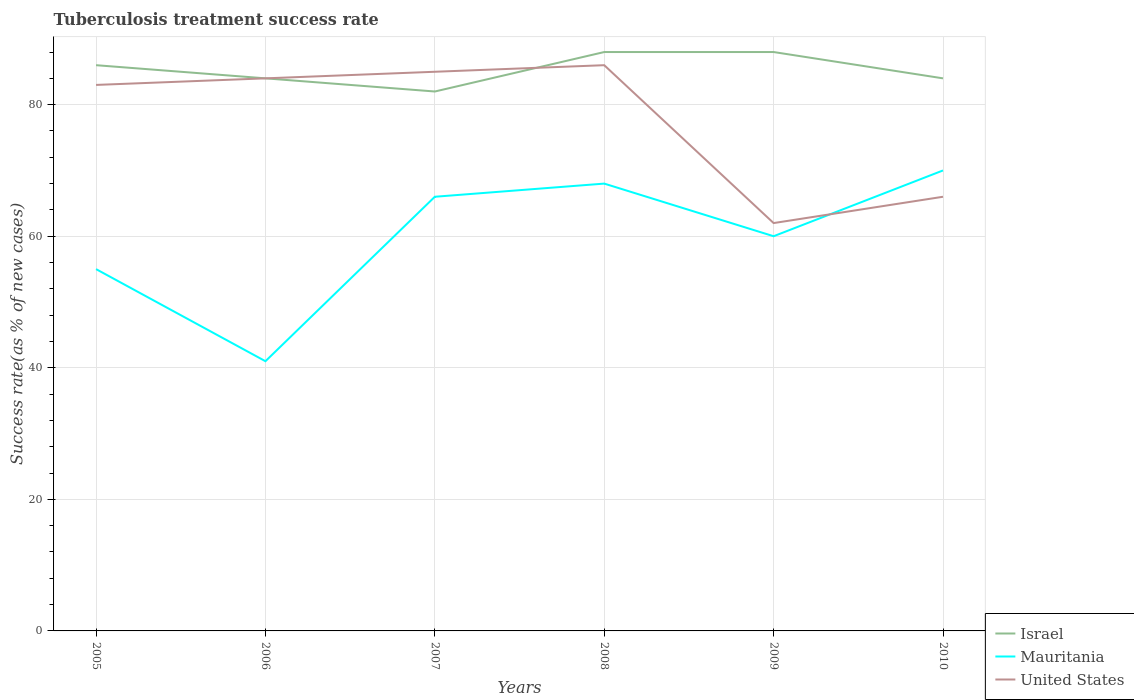How many different coloured lines are there?
Make the answer very short. 3. Does the line corresponding to United States intersect with the line corresponding to Israel?
Provide a short and direct response. Yes. Across all years, what is the maximum tuberculosis treatment success rate in Mauritania?
Provide a short and direct response. 41. What is the difference between the highest and the second highest tuberculosis treatment success rate in Israel?
Offer a terse response. 6. How many years are there in the graph?
Offer a very short reply. 6. What is the difference between two consecutive major ticks on the Y-axis?
Keep it short and to the point. 20. How many legend labels are there?
Your answer should be compact. 3. What is the title of the graph?
Give a very brief answer. Tuberculosis treatment success rate. What is the label or title of the X-axis?
Make the answer very short. Years. What is the label or title of the Y-axis?
Give a very brief answer. Success rate(as % of new cases). What is the Success rate(as % of new cases) of Israel in 2005?
Your answer should be very brief. 86. What is the Success rate(as % of new cases) of Israel in 2006?
Give a very brief answer. 84. What is the Success rate(as % of new cases) of Mauritania in 2006?
Your answer should be compact. 41. What is the Success rate(as % of new cases) in United States in 2006?
Ensure brevity in your answer.  84. What is the Success rate(as % of new cases) of Mauritania in 2007?
Your answer should be compact. 66. What is the Success rate(as % of new cases) of United States in 2008?
Your response must be concise. 86. Across all years, what is the minimum Success rate(as % of new cases) in Israel?
Your response must be concise. 82. What is the total Success rate(as % of new cases) of Israel in the graph?
Give a very brief answer. 512. What is the total Success rate(as % of new cases) of Mauritania in the graph?
Your response must be concise. 360. What is the total Success rate(as % of new cases) of United States in the graph?
Provide a short and direct response. 466. What is the difference between the Success rate(as % of new cases) of Mauritania in 2005 and that in 2006?
Keep it short and to the point. 14. What is the difference between the Success rate(as % of new cases) of Israel in 2005 and that in 2007?
Provide a succinct answer. 4. What is the difference between the Success rate(as % of new cases) of United States in 2005 and that in 2007?
Ensure brevity in your answer.  -2. What is the difference between the Success rate(as % of new cases) in Israel in 2005 and that in 2008?
Your response must be concise. -2. What is the difference between the Success rate(as % of new cases) in Mauritania in 2005 and that in 2008?
Ensure brevity in your answer.  -13. What is the difference between the Success rate(as % of new cases) in United States in 2005 and that in 2008?
Offer a terse response. -3. What is the difference between the Success rate(as % of new cases) of Mauritania in 2005 and that in 2009?
Your answer should be compact. -5. What is the difference between the Success rate(as % of new cases) in United States in 2005 and that in 2009?
Your answer should be very brief. 21. What is the difference between the Success rate(as % of new cases) of Mauritania in 2005 and that in 2010?
Keep it short and to the point. -15. What is the difference between the Success rate(as % of new cases) in United States in 2005 and that in 2010?
Make the answer very short. 17. What is the difference between the Success rate(as % of new cases) of Mauritania in 2006 and that in 2007?
Offer a terse response. -25. What is the difference between the Success rate(as % of new cases) in United States in 2006 and that in 2007?
Offer a terse response. -1. What is the difference between the Success rate(as % of new cases) in Israel in 2006 and that in 2009?
Offer a very short reply. -4. What is the difference between the Success rate(as % of new cases) of Mauritania in 2006 and that in 2009?
Ensure brevity in your answer.  -19. What is the difference between the Success rate(as % of new cases) in United States in 2006 and that in 2010?
Offer a very short reply. 18. What is the difference between the Success rate(as % of new cases) of Mauritania in 2007 and that in 2008?
Keep it short and to the point. -2. What is the difference between the Success rate(as % of new cases) of United States in 2007 and that in 2008?
Ensure brevity in your answer.  -1. What is the difference between the Success rate(as % of new cases) in Israel in 2007 and that in 2009?
Give a very brief answer. -6. What is the difference between the Success rate(as % of new cases) in United States in 2007 and that in 2010?
Make the answer very short. 19. What is the difference between the Success rate(as % of new cases) of Israel in 2008 and that in 2009?
Ensure brevity in your answer.  0. What is the difference between the Success rate(as % of new cases) in United States in 2008 and that in 2009?
Provide a succinct answer. 24. What is the difference between the Success rate(as % of new cases) in Mauritania in 2008 and that in 2010?
Ensure brevity in your answer.  -2. What is the difference between the Success rate(as % of new cases) of Israel in 2009 and that in 2010?
Your answer should be compact. 4. What is the difference between the Success rate(as % of new cases) of Mauritania in 2009 and that in 2010?
Provide a succinct answer. -10. What is the difference between the Success rate(as % of new cases) in United States in 2009 and that in 2010?
Make the answer very short. -4. What is the difference between the Success rate(as % of new cases) of Israel in 2005 and the Success rate(as % of new cases) of Mauritania in 2006?
Provide a succinct answer. 45. What is the difference between the Success rate(as % of new cases) of Israel in 2005 and the Success rate(as % of new cases) of United States in 2007?
Keep it short and to the point. 1. What is the difference between the Success rate(as % of new cases) in Israel in 2005 and the Success rate(as % of new cases) in Mauritania in 2008?
Make the answer very short. 18. What is the difference between the Success rate(as % of new cases) of Mauritania in 2005 and the Success rate(as % of new cases) of United States in 2008?
Give a very brief answer. -31. What is the difference between the Success rate(as % of new cases) in Israel in 2005 and the Success rate(as % of new cases) in Mauritania in 2009?
Provide a succinct answer. 26. What is the difference between the Success rate(as % of new cases) of Israel in 2005 and the Success rate(as % of new cases) of United States in 2009?
Provide a short and direct response. 24. What is the difference between the Success rate(as % of new cases) in Mauritania in 2005 and the Success rate(as % of new cases) in United States in 2009?
Your response must be concise. -7. What is the difference between the Success rate(as % of new cases) of Mauritania in 2005 and the Success rate(as % of new cases) of United States in 2010?
Provide a short and direct response. -11. What is the difference between the Success rate(as % of new cases) of Israel in 2006 and the Success rate(as % of new cases) of Mauritania in 2007?
Keep it short and to the point. 18. What is the difference between the Success rate(as % of new cases) of Israel in 2006 and the Success rate(as % of new cases) of United States in 2007?
Your response must be concise. -1. What is the difference between the Success rate(as % of new cases) in Mauritania in 2006 and the Success rate(as % of new cases) in United States in 2007?
Give a very brief answer. -44. What is the difference between the Success rate(as % of new cases) of Mauritania in 2006 and the Success rate(as % of new cases) of United States in 2008?
Keep it short and to the point. -45. What is the difference between the Success rate(as % of new cases) of Israel in 2006 and the Success rate(as % of new cases) of Mauritania in 2009?
Offer a very short reply. 24. What is the difference between the Success rate(as % of new cases) of Israel in 2006 and the Success rate(as % of new cases) of United States in 2009?
Offer a very short reply. 22. What is the difference between the Success rate(as % of new cases) of Mauritania in 2006 and the Success rate(as % of new cases) of United States in 2009?
Provide a succinct answer. -21. What is the difference between the Success rate(as % of new cases) in Israel in 2006 and the Success rate(as % of new cases) in Mauritania in 2010?
Your answer should be compact. 14. What is the difference between the Success rate(as % of new cases) of Mauritania in 2006 and the Success rate(as % of new cases) of United States in 2010?
Provide a succinct answer. -25. What is the difference between the Success rate(as % of new cases) of Israel in 2007 and the Success rate(as % of new cases) of Mauritania in 2008?
Your answer should be very brief. 14. What is the difference between the Success rate(as % of new cases) of Israel in 2007 and the Success rate(as % of new cases) of Mauritania in 2009?
Your response must be concise. 22. What is the difference between the Success rate(as % of new cases) in Israel in 2007 and the Success rate(as % of new cases) in United States in 2009?
Give a very brief answer. 20. What is the difference between the Success rate(as % of new cases) in Mauritania in 2007 and the Success rate(as % of new cases) in United States in 2009?
Offer a very short reply. 4. What is the difference between the Success rate(as % of new cases) in Mauritania in 2007 and the Success rate(as % of new cases) in United States in 2010?
Give a very brief answer. 0. What is the difference between the Success rate(as % of new cases) of Mauritania in 2008 and the Success rate(as % of new cases) of United States in 2009?
Ensure brevity in your answer.  6. What is the difference between the Success rate(as % of new cases) in Israel in 2008 and the Success rate(as % of new cases) in Mauritania in 2010?
Provide a succinct answer. 18. What is the difference between the Success rate(as % of new cases) in Israel in 2008 and the Success rate(as % of new cases) in United States in 2010?
Provide a short and direct response. 22. What is the difference between the Success rate(as % of new cases) in Mauritania in 2008 and the Success rate(as % of new cases) in United States in 2010?
Keep it short and to the point. 2. What is the difference between the Success rate(as % of new cases) of Israel in 2009 and the Success rate(as % of new cases) of Mauritania in 2010?
Ensure brevity in your answer.  18. What is the difference between the Success rate(as % of new cases) in Israel in 2009 and the Success rate(as % of new cases) in United States in 2010?
Your answer should be compact. 22. What is the difference between the Success rate(as % of new cases) of Mauritania in 2009 and the Success rate(as % of new cases) of United States in 2010?
Your answer should be compact. -6. What is the average Success rate(as % of new cases) in Israel per year?
Offer a very short reply. 85.33. What is the average Success rate(as % of new cases) in United States per year?
Your response must be concise. 77.67. In the year 2005, what is the difference between the Success rate(as % of new cases) in Israel and Success rate(as % of new cases) in United States?
Keep it short and to the point. 3. In the year 2005, what is the difference between the Success rate(as % of new cases) of Mauritania and Success rate(as % of new cases) of United States?
Provide a short and direct response. -28. In the year 2006, what is the difference between the Success rate(as % of new cases) in Israel and Success rate(as % of new cases) in Mauritania?
Offer a terse response. 43. In the year 2006, what is the difference between the Success rate(as % of new cases) in Israel and Success rate(as % of new cases) in United States?
Offer a terse response. 0. In the year 2006, what is the difference between the Success rate(as % of new cases) of Mauritania and Success rate(as % of new cases) of United States?
Provide a short and direct response. -43. In the year 2007, what is the difference between the Success rate(as % of new cases) of Israel and Success rate(as % of new cases) of Mauritania?
Ensure brevity in your answer.  16. In the year 2009, what is the difference between the Success rate(as % of new cases) in Israel and Success rate(as % of new cases) in United States?
Your answer should be very brief. 26. In the year 2010, what is the difference between the Success rate(as % of new cases) in Israel and Success rate(as % of new cases) in United States?
Your answer should be compact. 18. In the year 2010, what is the difference between the Success rate(as % of new cases) in Mauritania and Success rate(as % of new cases) in United States?
Offer a very short reply. 4. What is the ratio of the Success rate(as % of new cases) in Israel in 2005 to that in 2006?
Make the answer very short. 1.02. What is the ratio of the Success rate(as % of new cases) of Mauritania in 2005 to that in 2006?
Ensure brevity in your answer.  1.34. What is the ratio of the Success rate(as % of new cases) of United States in 2005 to that in 2006?
Give a very brief answer. 0.99. What is the ratio of the Success rate(as % of new cases) in Israel in 2005 to that in 2007?
Keep it short and to the point. 1.05. What is the ratio of the Success rate(as % of new cases) in Mauritania in 2005 to that in 2007?
Make the answer very short. 0.83. What is the ratio of the Success rate(as % of new cases) of United States in 2005 to that in 2007?
Your response must be concise. 0.98. What is the ratio of the Success rate(as % of new cases) of Israel in 2005 to that in 2008?
Your answer should be very brief. 0.98. What is the ratio of the Success rate(as % of new cases) of Mauritania in 2005 to that in 2008?
Make the answer very short. 0.81. What is the ratio of the Success rate(as % of new cases) in United States in 2005 to that in 2008?
Your answer should be very brief. 0.97. What is the ratio of the Success rate(as % of new cases) of Israel in 2005 to that in 2009?
Your answer should be very brief. 0.98. What is the ratio of the Success rate(as % of new cases) in Mauritania in 2005 to that in 2009?
Make the answer very short. 0.92. What is the ratio of the Success rate(as % of new cases) of United States in 2005 to that in 2009?
Your response must be concise. 1.34. What is the ratio of the Success rate(as % of new cases) in Israel in 2005 to that in 2010?
Provide a succinct answer. 1.02. What is the ratio of the Success rate(as % of new cases) in Mauritania in 2005 to that in 2010?
Offer a very short reply. 0.79. What is the ratio of the Success rate(as % of new cases) of United States in 2005 to that in 2010?
Give a very brief answer. 1.26. What is the ratio of the Success rate(as % of new cases) in Israel in 2006 to that in 2007?
Provide a short and direct response. 1.02. What is the ratio of the Success rate(as % of new cases) in Mauritania in 2006 to that in 2007?
Your response must be concise. 0.62. What is the ratio of the Success rate(as % of new cases) in Israel in 2006 to that in 2008?
Ensure brevity in your answer.  0.95. What is the ratio of the Success rate(as % of new cases) of Mauritania in 2006 to that in 2008?
Offer a terse response. 0.6. What is the ratio of the Success rate(as % of new cases) in United States in 2006 to that in 2008?
Your response must be concise. 0.98. What is the ratio of the Success rate(as % of new cases) in Israel in 2006 to that in 2009?
Ensure brevity in your answer.  0.95. What is the ratio of the Success rate(as % of new cases) in Mauritania in 2006 to that in 2009?
Keep it short and to the point. 0.68. What is the ratio of the Success rate(as % of new cases) in United States in 2006 to that in 2009?
Your answer should be compact. 1.35. What is the ratio of the Success rate(as % of new cases) in Israel in 2006 to that in 2010?
Ensure brevity in your answer.  1. What is the ratio of the Success rate(as % of new cases) in Mauritania in 2006 to that in 2010?
Ensure brevity in your answer.  0.59. What is the ratio of the Success rate(as % of new cases) of United States in 2006 to that in 2010?
Offer a terse response. 1.27. What is the ratio of the Success rate(as % of new cases) of Israel in 2007 to that in 2008?
Provide a short and direct response. 0.93. What is the ratio of the Success rate(as % of new cases) of Mauritania in 2007 to that in 2008?
Keep it short and to the point. 0.97. What is the ratio of the Success rate(as % of new cases) of United States in 2007 to that in 2008?
Ensure brevity in your answer.  0.99. What is the ratio of the Success rate(as % of new cases) of Israel in 2007 to that in 2009?
Your answer should be compact. 0.93. What is the ratio of the Success rate(as % of new cases) of Mauritania in 2007 to that in 2009?
Your response must be concise. 1.1. What is the ratio of the Success rate(as % of new cases) in United States in 2007 to that in 2009?
Make the answer very short. 1.37. What is the ratio of the Success rate(as % of new cases) of Israel in 2007 to that in 2010?
Offer a terse response. 0.98. What is the ratio of the Success rate(as % of new cases) in Mauritania in 2007 to that in 2010?
Your response must be concise. 0.94. What is the ratio of the Success rate(as % of new cases) in United States in 2007 to that in 2010?
Keep it short and to the point. 1.29. What is the ratio of the Success rate(as % of new cases) of Israel in 2008 to that in 2009?
Your answer should be very brief. 1. What is the ratio of the Success rate(as % of new cases) of Mauritania in 2008 to that in 2009?
Ensure brevity in your answer.  1.13. What is the ratio of the Success rate(as % of new cases) of United States in 2008 to that in 2009?
Keep it short and to the point. 1.39. What is the ratio of the Success rate(as % of new cases) of Israel in 2008 to that in 2010?
Provide a short and direct response. 1.05. What is the ratio of the Success rate(as % of new cases) of Mauritania in 2008 to that in 2010?
Ensure brevity in your answer.  0.97. What is the ratio of the Success rate(as % of new cases) of United States in 2008 to that in 2010?
Give a very brief answer. 1.3. What is the ratio of the Success rate(as % of new cases) of Israel in 2009 to that in 2010?
Provide a succinct answer. 1.05. What is the ratio of the Success rate(as % of new cases) in Mauritania in 2009 to that in 2010?
Make the answer very short. 0.86. What is the ratio of the Success rate(as % of new cases) of United States in 2009 to that in 2010?
Provide a succinct answer. 0.94. What is the difference between the highest and the lowest Success rate(as % of new cases) of Mauritania?
Make the answer very short. 29. 